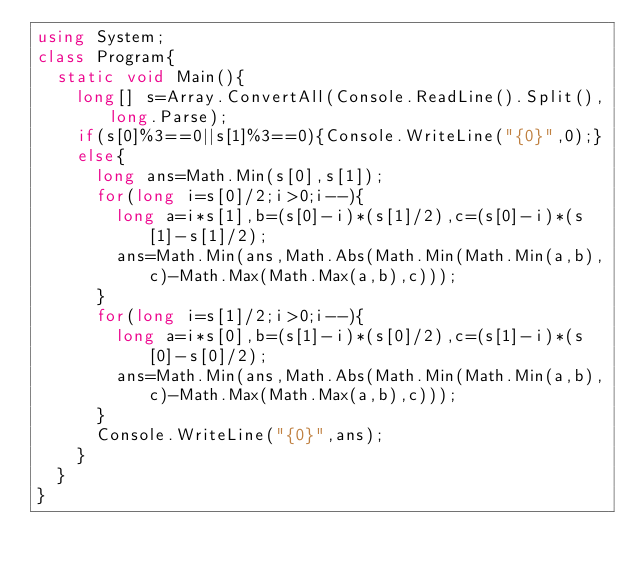<code> <loc_0><loc_0><loc_500><loc_500><_C#_>using System;
class Program{
	static void Main(){
		long[] s=Array.ConvertAll(Console.ReadLine().Split(),long.Parse);
		if(s[0]%3==0||s[1]%3==0){Console.WriteLine("{0}",0);}
		else{
			long ans=Math.Min(s[0],s[1]);
			for(long i=s[0]/2;i>0;i--){
				long a=i*s[1],b=(s[0]-i)*(s[1]/2),c=(s[0]-i)*(s[1]-s[1]/2);
				ans=Math.Min(ans,Math.Abs(Math.Min(Math.Min(a,b),c)-Math.Max(Math.Max(a,b),c)));
			}
			for(long i=s[1]/2;i>0;i--){
				long a=i*s[0],b=(s[1]-i)*(s[0]/2),c=(s[1]-i)*(s[0]-s[0]/2);
				ans=Math.Min(ans,Math.Abs(Math.Min(Math.Min(a,b),c)-Math.Max(Math.Max(a,b),c)));
			}
			Console.WriteLine("{0}",ans);
		}
	}
}</code> 